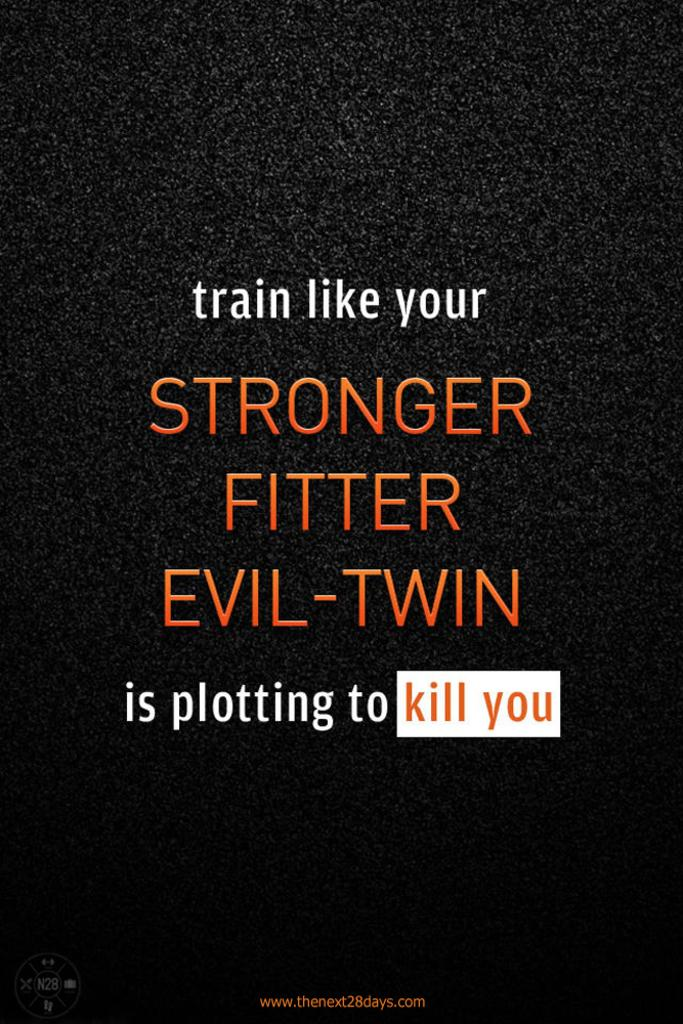<image>
Summarize the visual content of the image. Sign that says "Train like your evil twin is trying to kill you". 